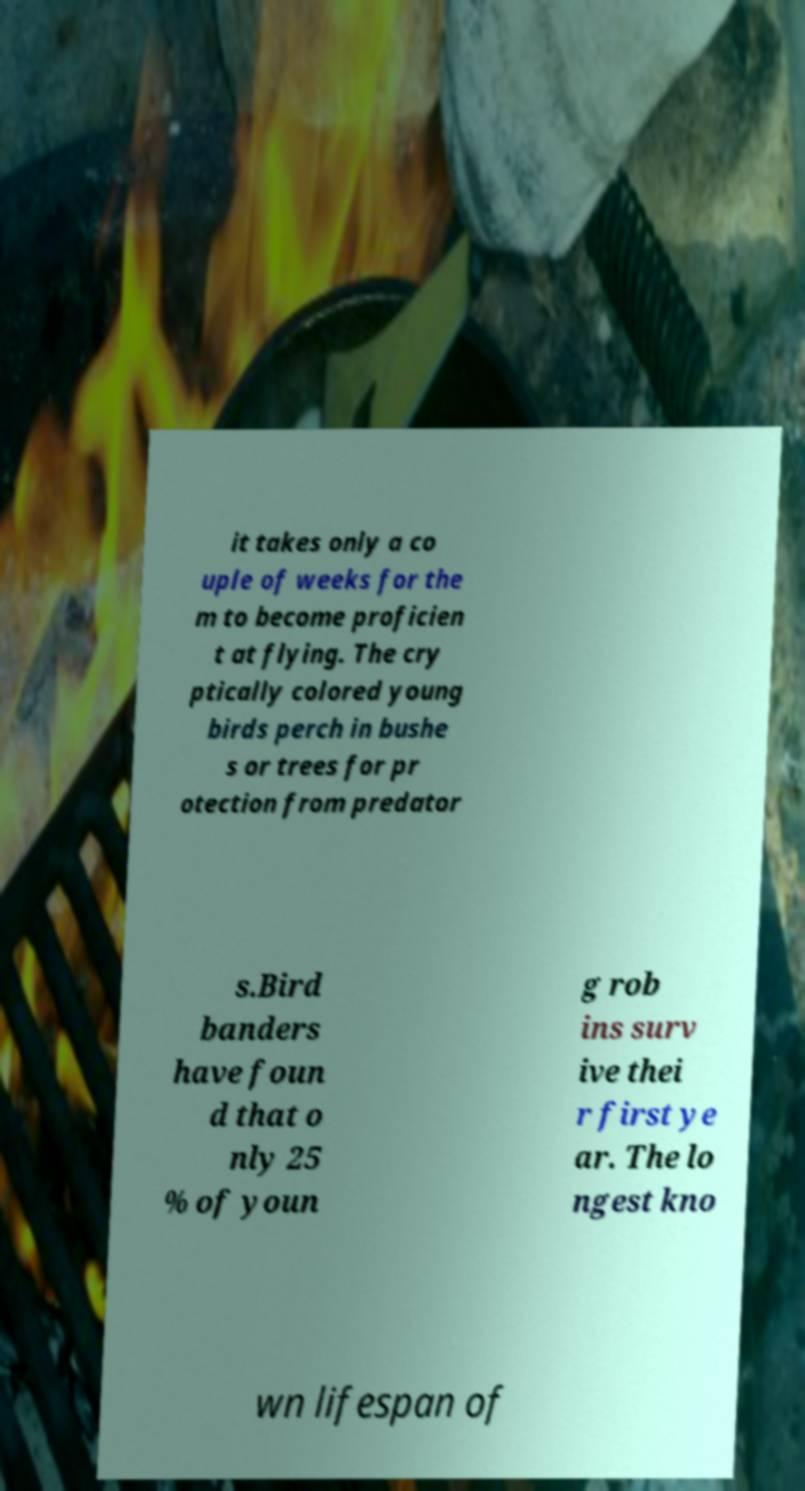Could you extract and type out the text from this image? it takes only a co uple of weeks for the m to become proficien t at flying. The cry ptically colored young birds perch in bushe s or trees for pr otection from predator s.Bird banders have foun d that o nly 25 % of youn g rob ins surv ive thei r first ye ar. The lo ngest kno wn lifespan of 